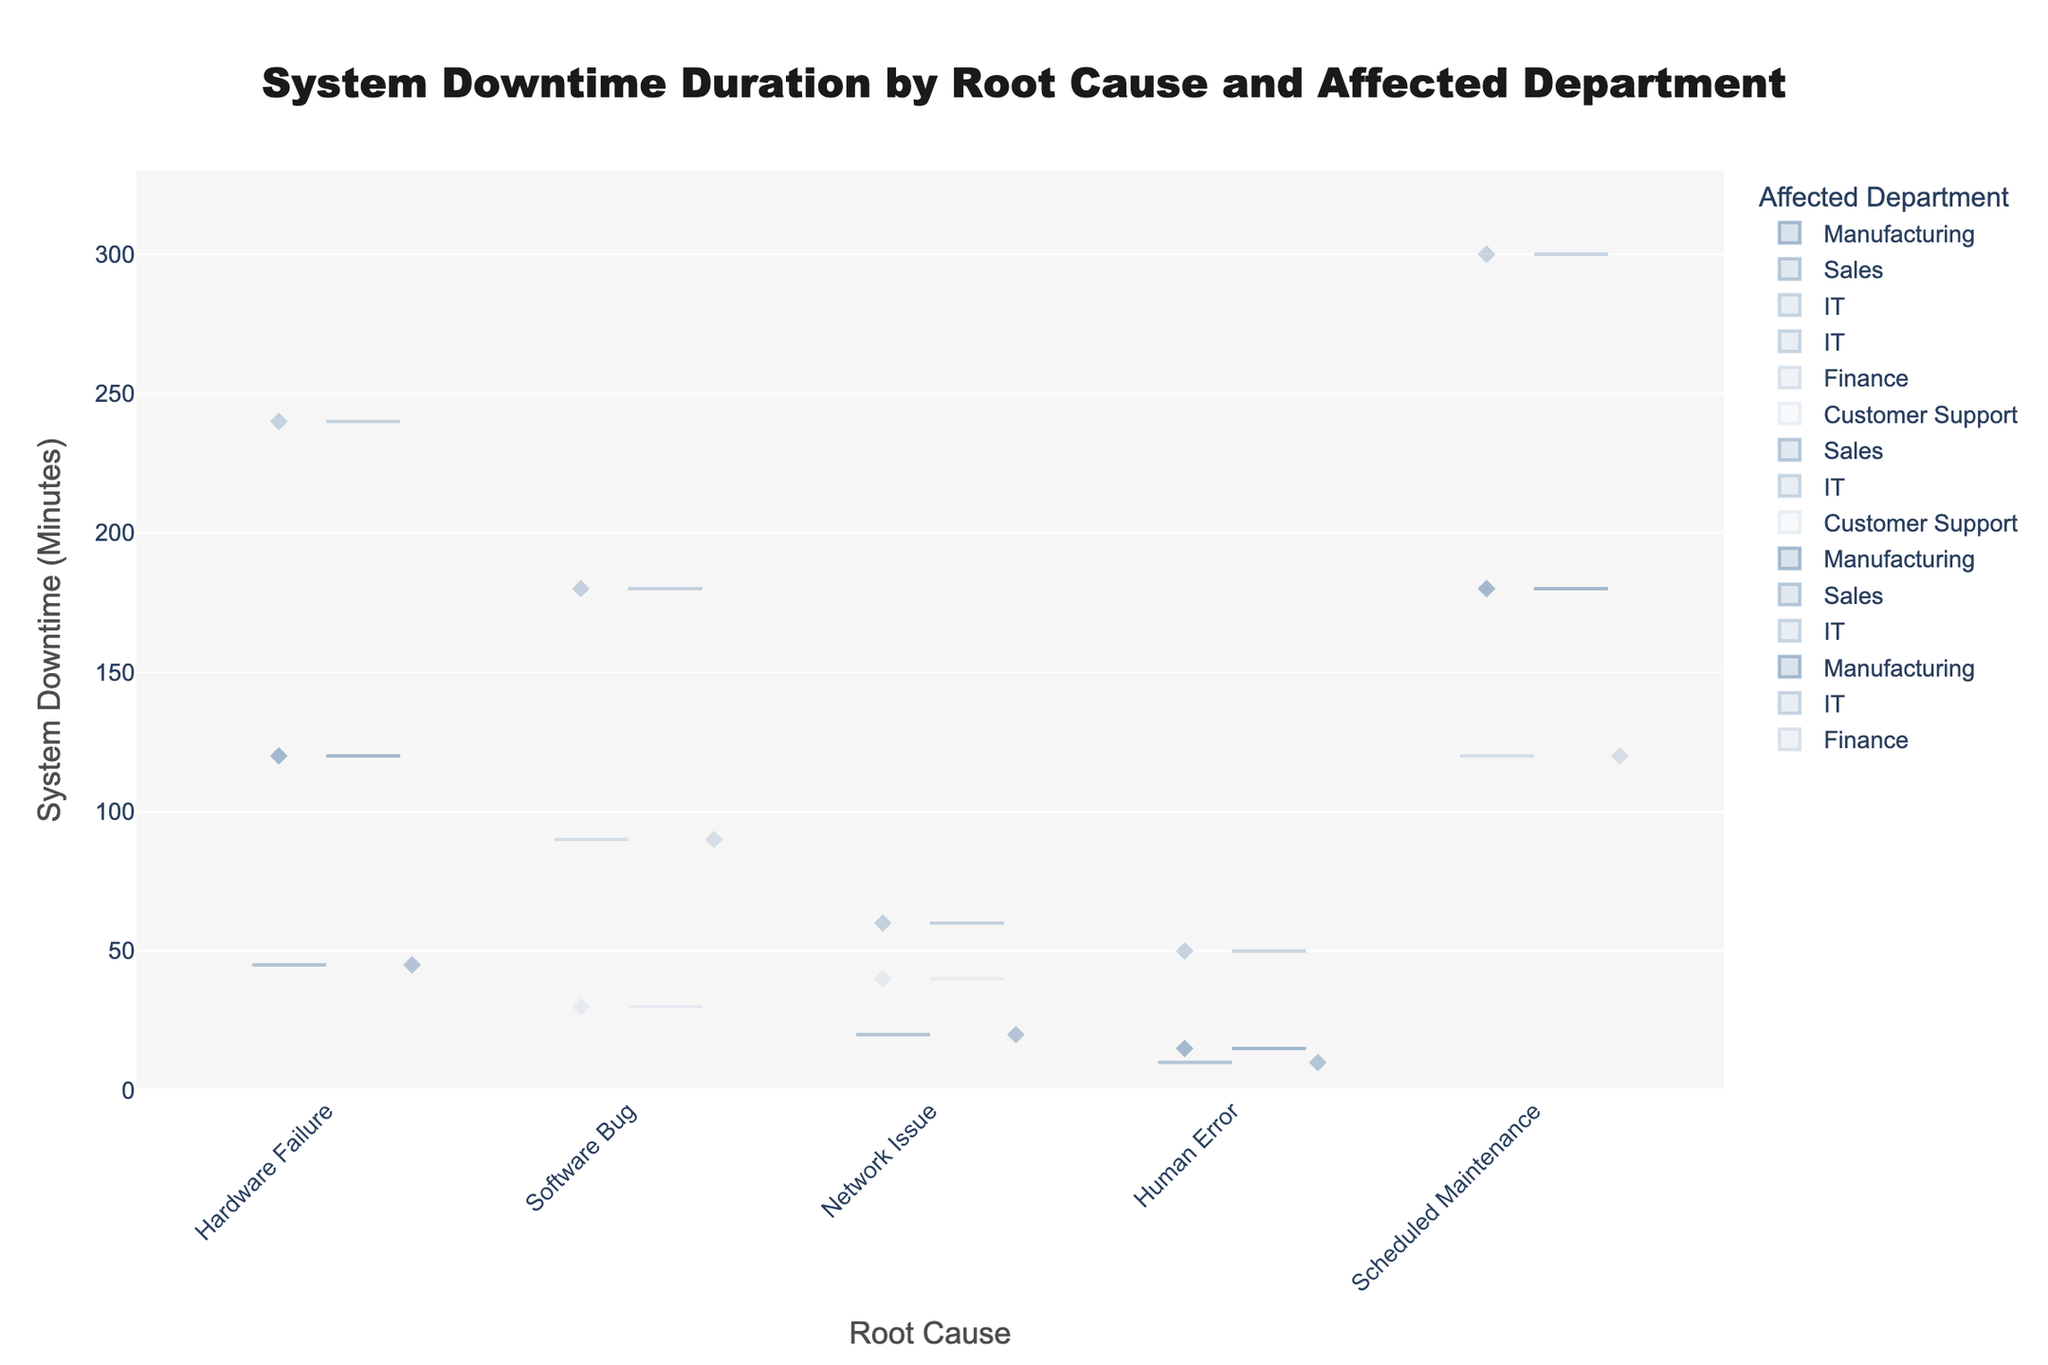How many root causes are displayed in the chart? Identify the unique values represented on the x-axis. The title indicates we are looking at 'System Downtime Duration by Root Cause and Affected Department', and we can see distinct categories on the x-axis.
Answer: 5 What department experienced the highest downtime due to scheduled maintenance? Look at the Scheduled Maintenance category on the x-axis and compare the lengths of the violins for each department. The IT department shows the highest values.
Answer: IT Which root cause resulted in the least downtime for the Sales department? Find the Sales department's violin plots under each root cause and identify the one with the smallest values. For Human Error, Sales has 10 minutes, which is the smallest.
Answer: Human Error What is the title of the figure? Text located at the top center, generally indicating the main focus of the chart.
Answer: System Downtime Duration by Root Cause and Affected Department Which root cause has the widest range of downtime durations in the IT department? Check the IT department's violins across the root causes to see which has the most spread out points. Hardware Failure has a range from 0 to 240 minutes, which is the widest.
Answer: Hardware Failure Compare the median downtime due to Software Bug and Network Issue for the Customer Support department? Look at the center point of the violins for Customer Support under Software Bug and Network Issue. Software Bug seems to center around 30 minutes, and Network Issue around 40 minutes.
Answer: 40 > 30 Are there any root causes where all departments have downtime durations greater than 100 minutes? Look at the violins for each department under each root cause and check if any of them stay consistently above 100 minutes. For Scheduled Maintenance, all departments (Finance, Manufacturing, IT) have values of or above 120 minutes.
Answer: Yes How many different departments are affected according to the chart? Look at the legend or identify unique department labels next to the violin plots.
Answer: 4 